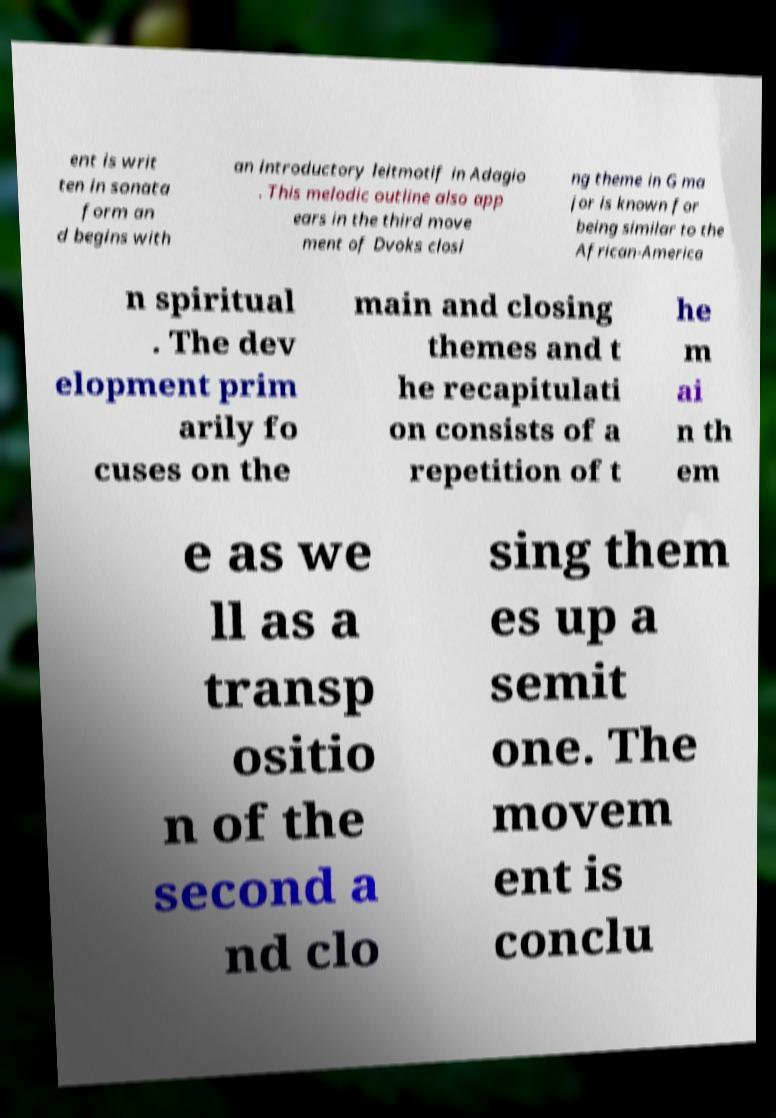What messages or text are displayed in this image? I need them in a readable, typed format. ent is writ ten in sonata form an d begins with an introductory leitmotif in Adagio . This melodic outline also app ears in the third move ment of Dvoks closi ng theme in G ma jor is known for being similar to the African-America n spiritual . The dev elopment prim arily fo cuses on the main and closing themes and t he recapitulati on consists of a repetition of t he m ai n th em e as we ll as a transp ositio n of the second a nd clo sing them es up a semit one. The movem ent is conclu 